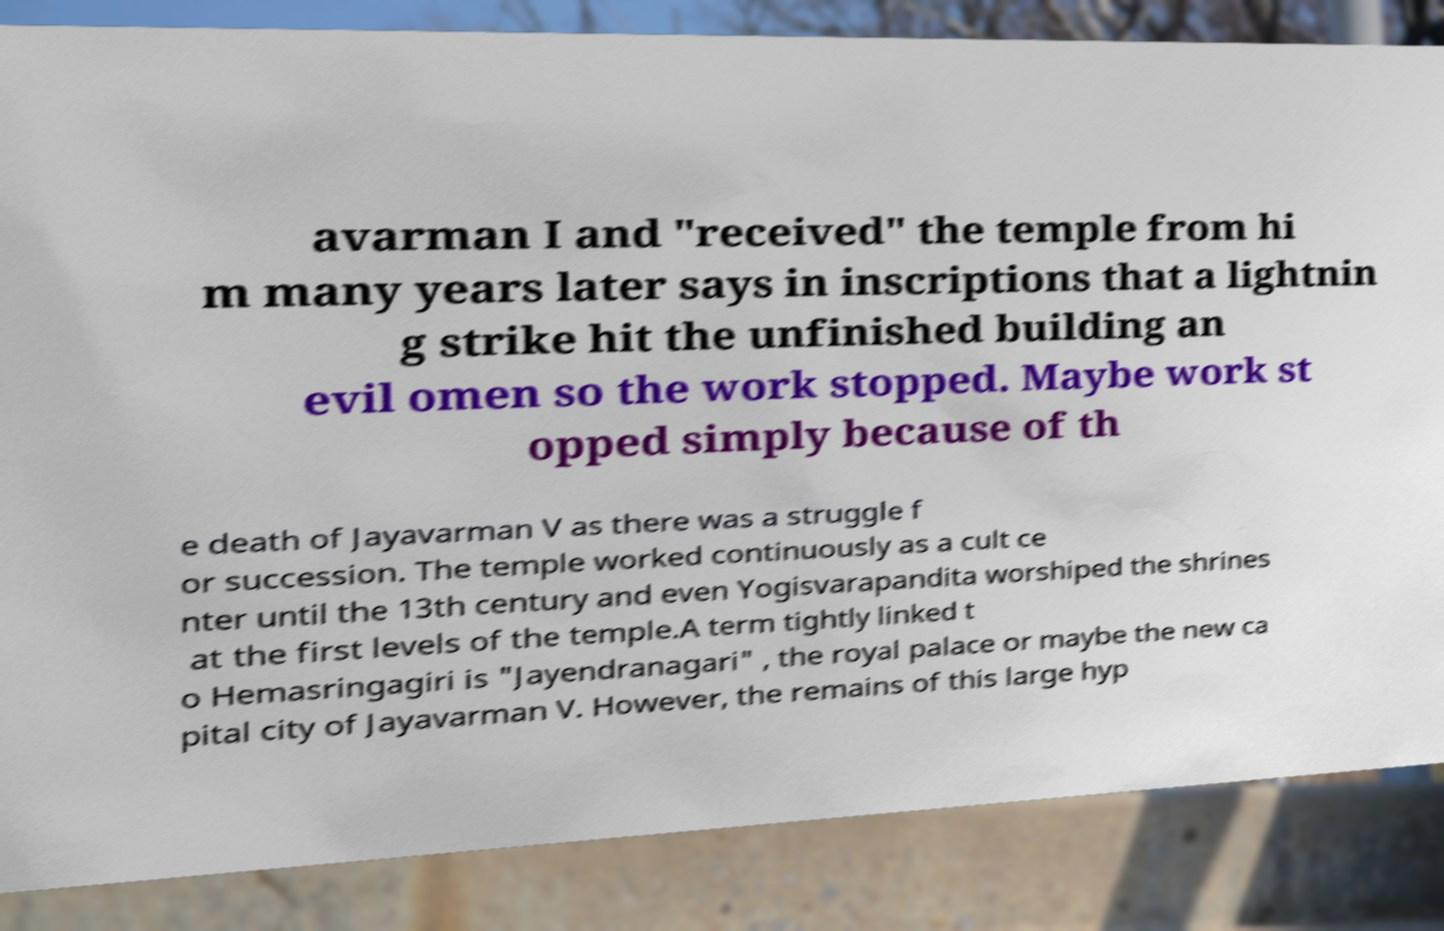Please read and relay the text visible in this image. What does it say? avarman I and "received" the temple from hi m many years later says in inscriptions that a lightnin g strike hit the unfinished building an evil omen so the work stopped. Maybe work st opped simply because of th e death of Jayavarman V as there was a struggle f or succession. The temple worked continuously as a cult ce nter until the 13th century and even Yogisvarapandita worshiped the shrines at the first levels of the temple.A term tightly linked t o Hemasringagiri is "Jayendranagari" , the royal palace or maybe the new ca pital city of Jayavarman V. However, the remains of this large hyp 